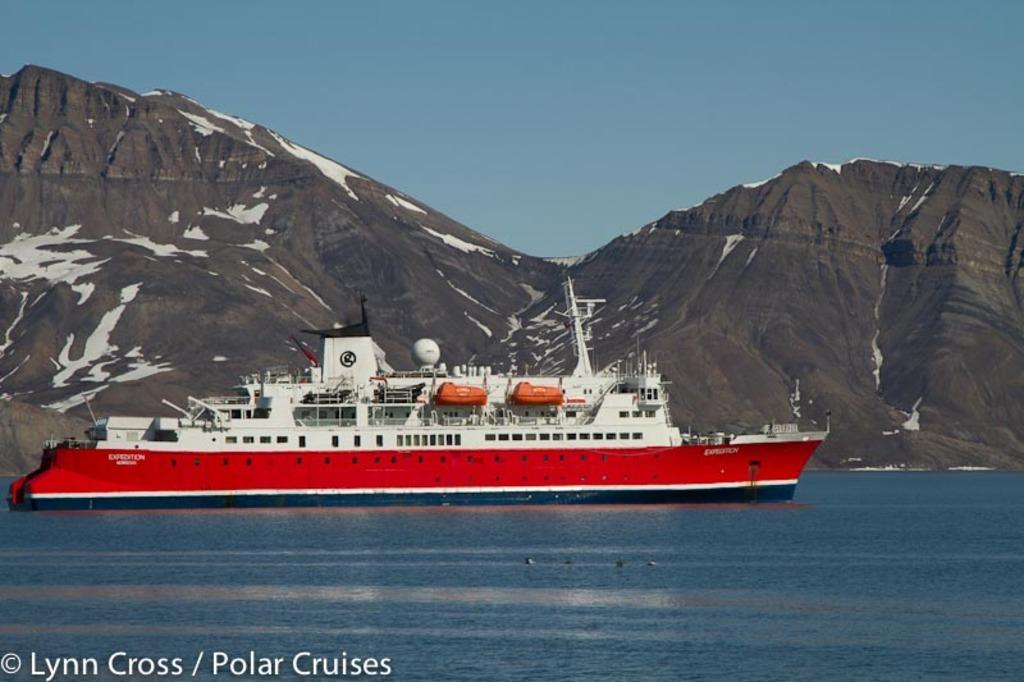What is the main subject in the center of the image? There is a ship in the center of the image. Where is the ship located? The ship is on the water. What can be seen in the background of the image? There are mountains in the background of the image. What is visible at the top of the image? The sky is visible at the top of the image. What is written at the bottom of the image? There is some text written at the bottom of the image. What type of linen is draped over the ship's railing in the image? There is no linen present in the image; it is a ship on the water with mountains in the background and text at the bottom. Can you see any rabbits hopping around the ship in the image? There are no rabbits present in the image; it is a ship on the water with mountains in the background and text at the bottom. 